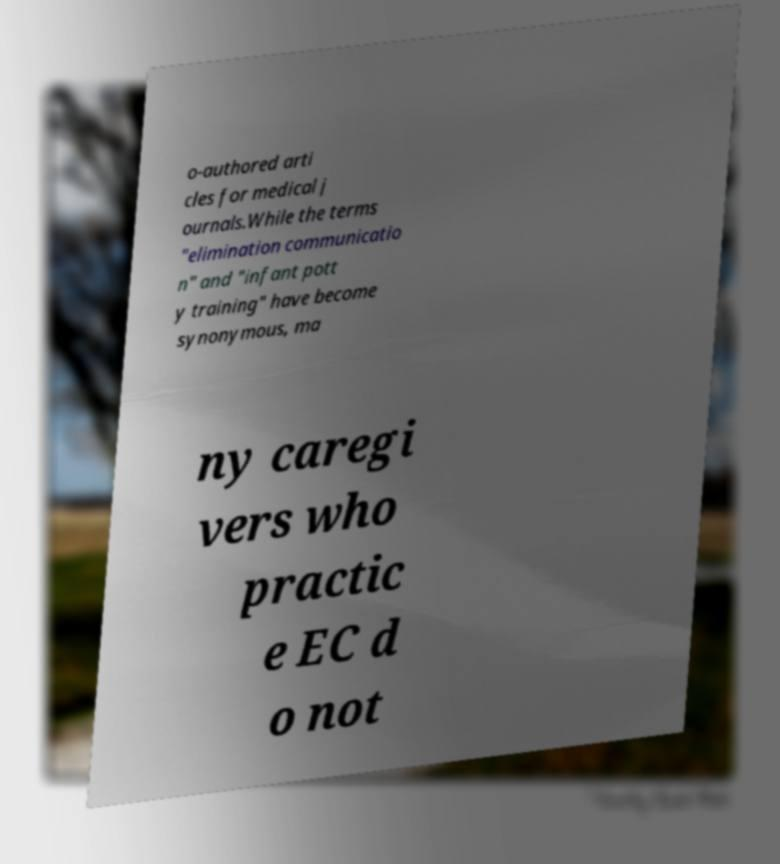Please read and relay the text visible in this image. What does it say? o-authored arti cles for medical j ournals.While the terms "elimination communicatio n" and "infant pott y training" have become synonymous, ma ny caregi vers who practic e EC d o not 